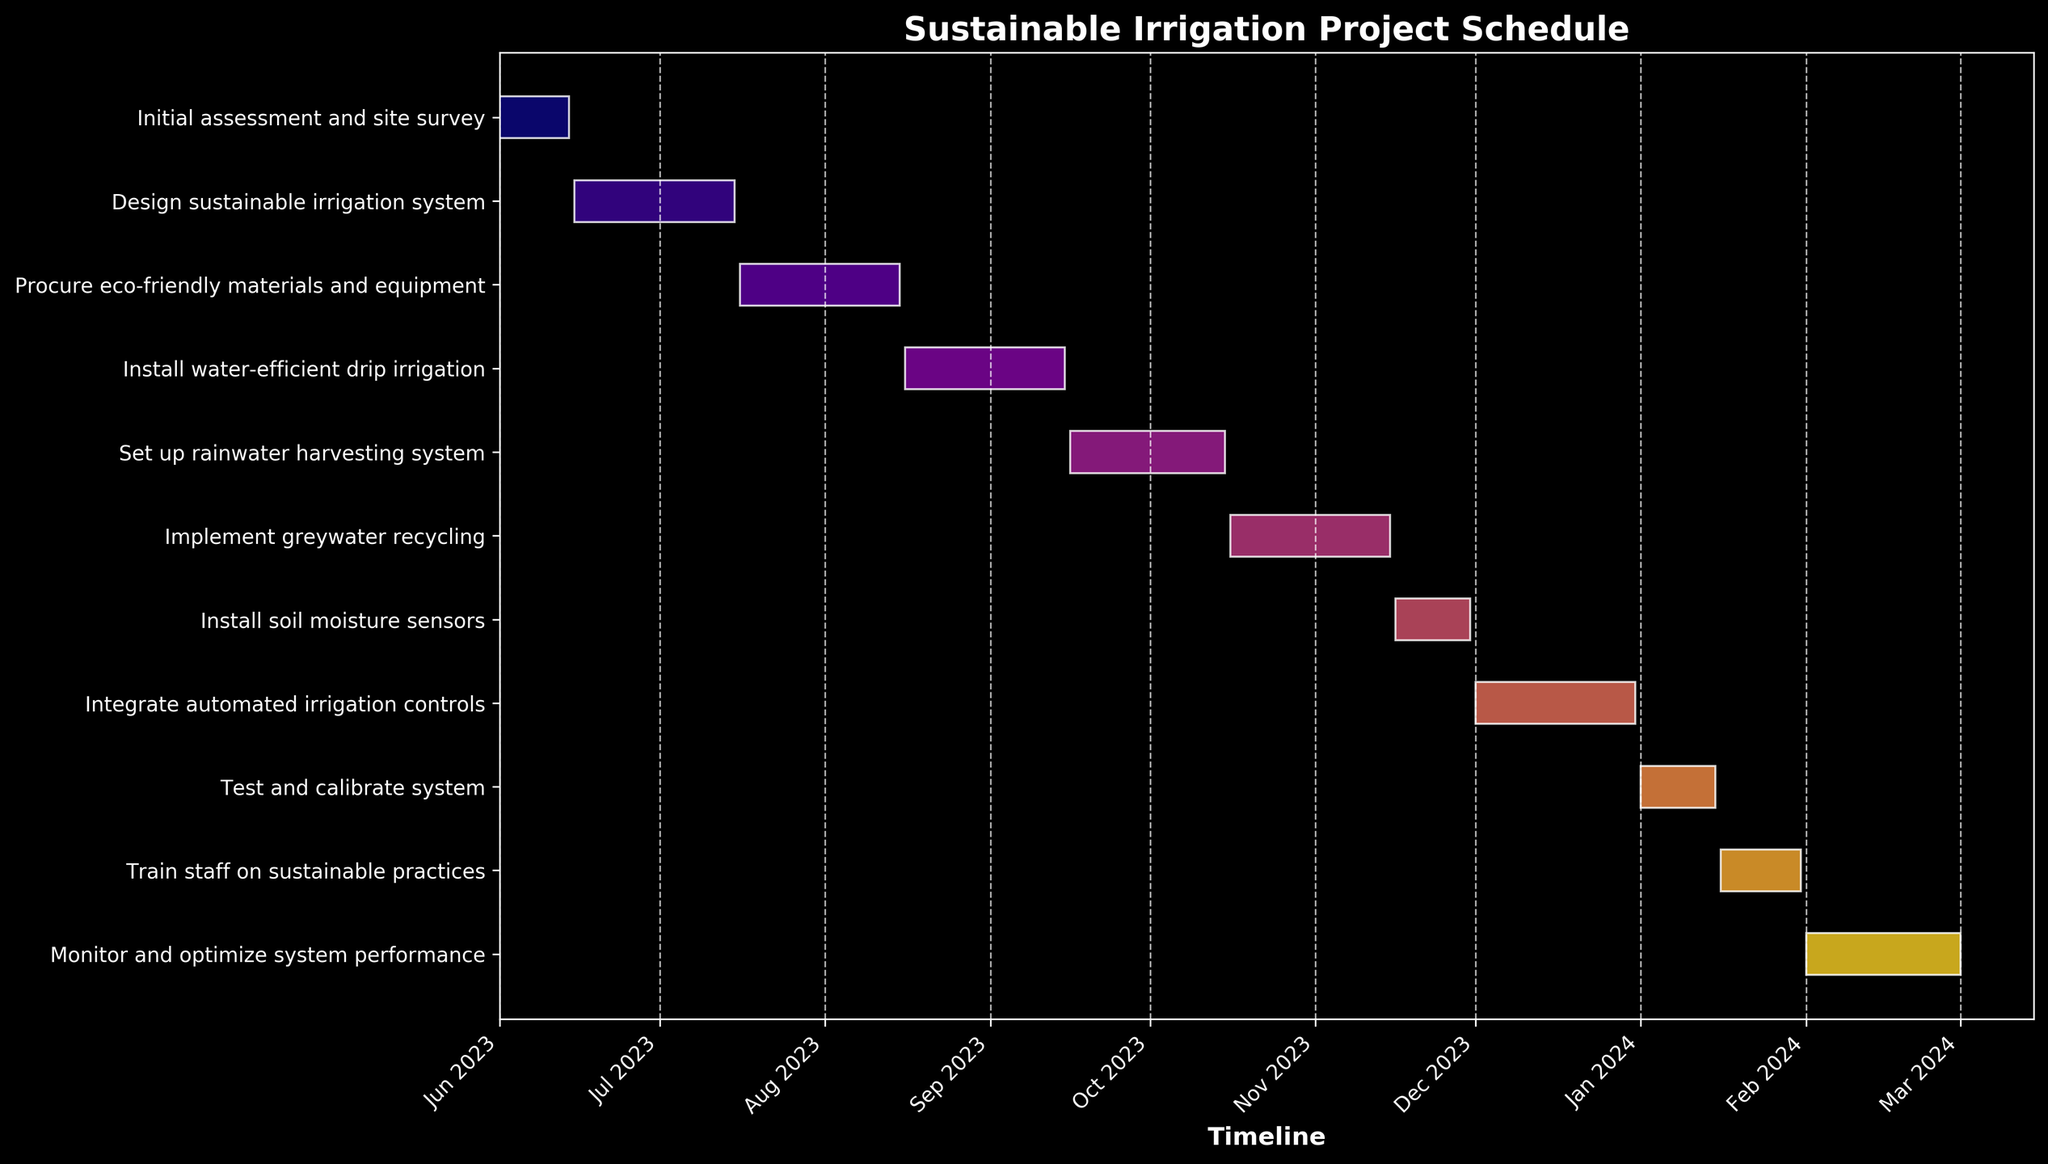What is the title of the project schedule? The title is displayed at the top of the chart. It typically summarizes the main purpose of the Gantt Chart.
Answer: Sustainable Irrigation Project Schedule Which task has the shortest duration? Compare the duration of all the tasks listed. The task with the smallest date range is the shortest.
Answer: Install soil moisture sensors How many tasks are scheduled to start in July 2023? Review the start dates of each task to find those that start in July 2023.
Answer: One task Which task starts immediately after the ‘Install water-efficient drip irrigation’ task? To find this, locate the end date of the ‘Install water-efficient drip irrigation’ task and identify the task that starts right after this date.
Answer: Set up rainwater harvesting system What is the total duration of tasks from the start of the project until the end of "Train staff on sustainable practices"? Find the start date of the first task and the end date of the "Train staff on sustainable practices" task. Calculate the total number of days between these two dates.
Answer: 245 days Which task ends on the same month it started? Identify tasks where the start and end dates fall within the same month.
Answer: Install soil moisture sensors Which month has the highest number of tasks in progress? Examine the Gantt Chart to determine which month has the most overlapping tasks in progress based on their start and end dates.
Answer: January 2024 What is the duration of the ‘Monitor and optimize system performance’ task in days? Reference the duration column for this specific task to find the number of days it spans.
Answer: 30 days How does the duration of 'Implement greywater recycling' compare with 'Test and calibrate system’? Compare the number of days scheduled for both tasks; subtract the duration of the shorter task from the longer task.
Answer: It is 16 days longer Are there any tasks that overlap with the ‘Design sustainable irrigation system’ task? Examine tasks whose start or end dates fall within the range of the ‘Design sustainable irrigation system’ task's dates.
Answer: No 